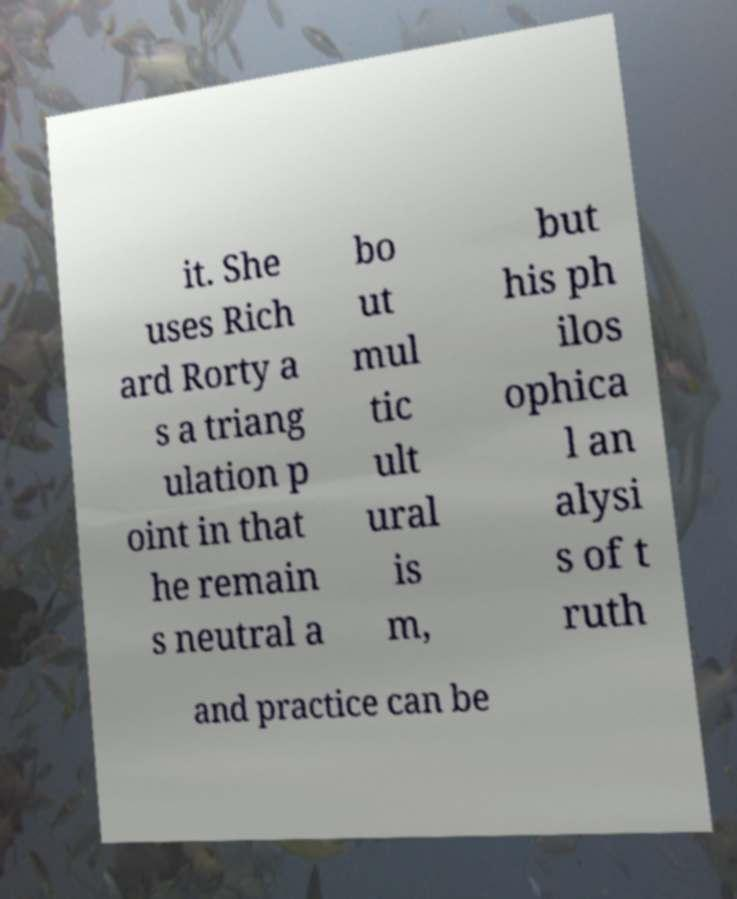Can you accurately transcribe the text from the provided image for me? it. She uses Rich ard Rorty a s a triang ulation p oint in that he remain s neutral a bo ut mul tic ult ural is m, but his ph ilos ophica l an alysi s of t ruth and practice can be 